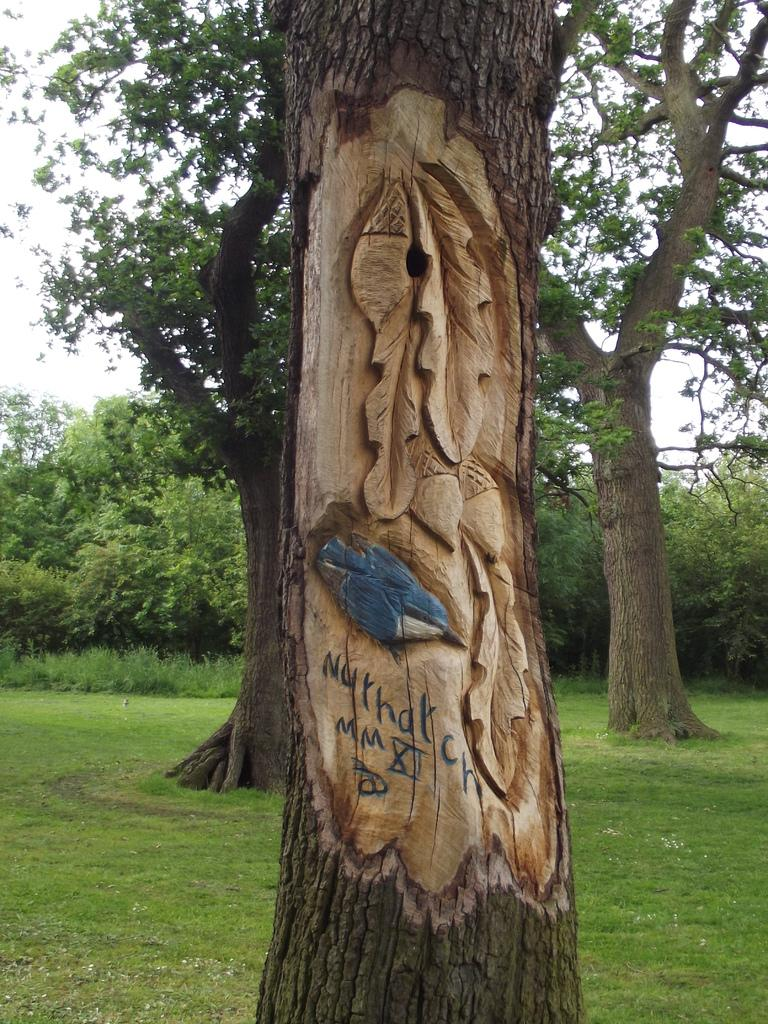What is on the tree trunk in the image? There is art and text on the tree trunk in the image. What can be seen in the background of the image? There are trees, plants, grass, and the sky visible in the background of the image. What type of chess pieces can be seen on the tree trunk in the image? There are no chess pieces present on the tree trunk in the image. Is there a box containing holiday decorations visible in the image? There is no box or reference to holiday decorations in the image. 